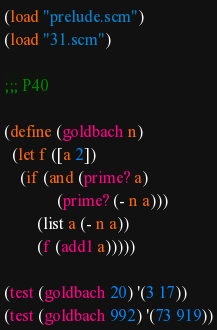Convert code to text. <code><loc_0><loc_0><loc_500><loc_500><_Scheme_>(load "prelude.scm")
(load "31.scm")

;;; P40

(define (goldbach n)
  (let f ([a 2])
    (if (and (prime? a)
             (prime? (- n a)))
        (list a (- n a))
        (f (add1 a)))))

(test (goldbach 20) '(3 17))
(test (goldbach 992) '(73 919))
</code> 